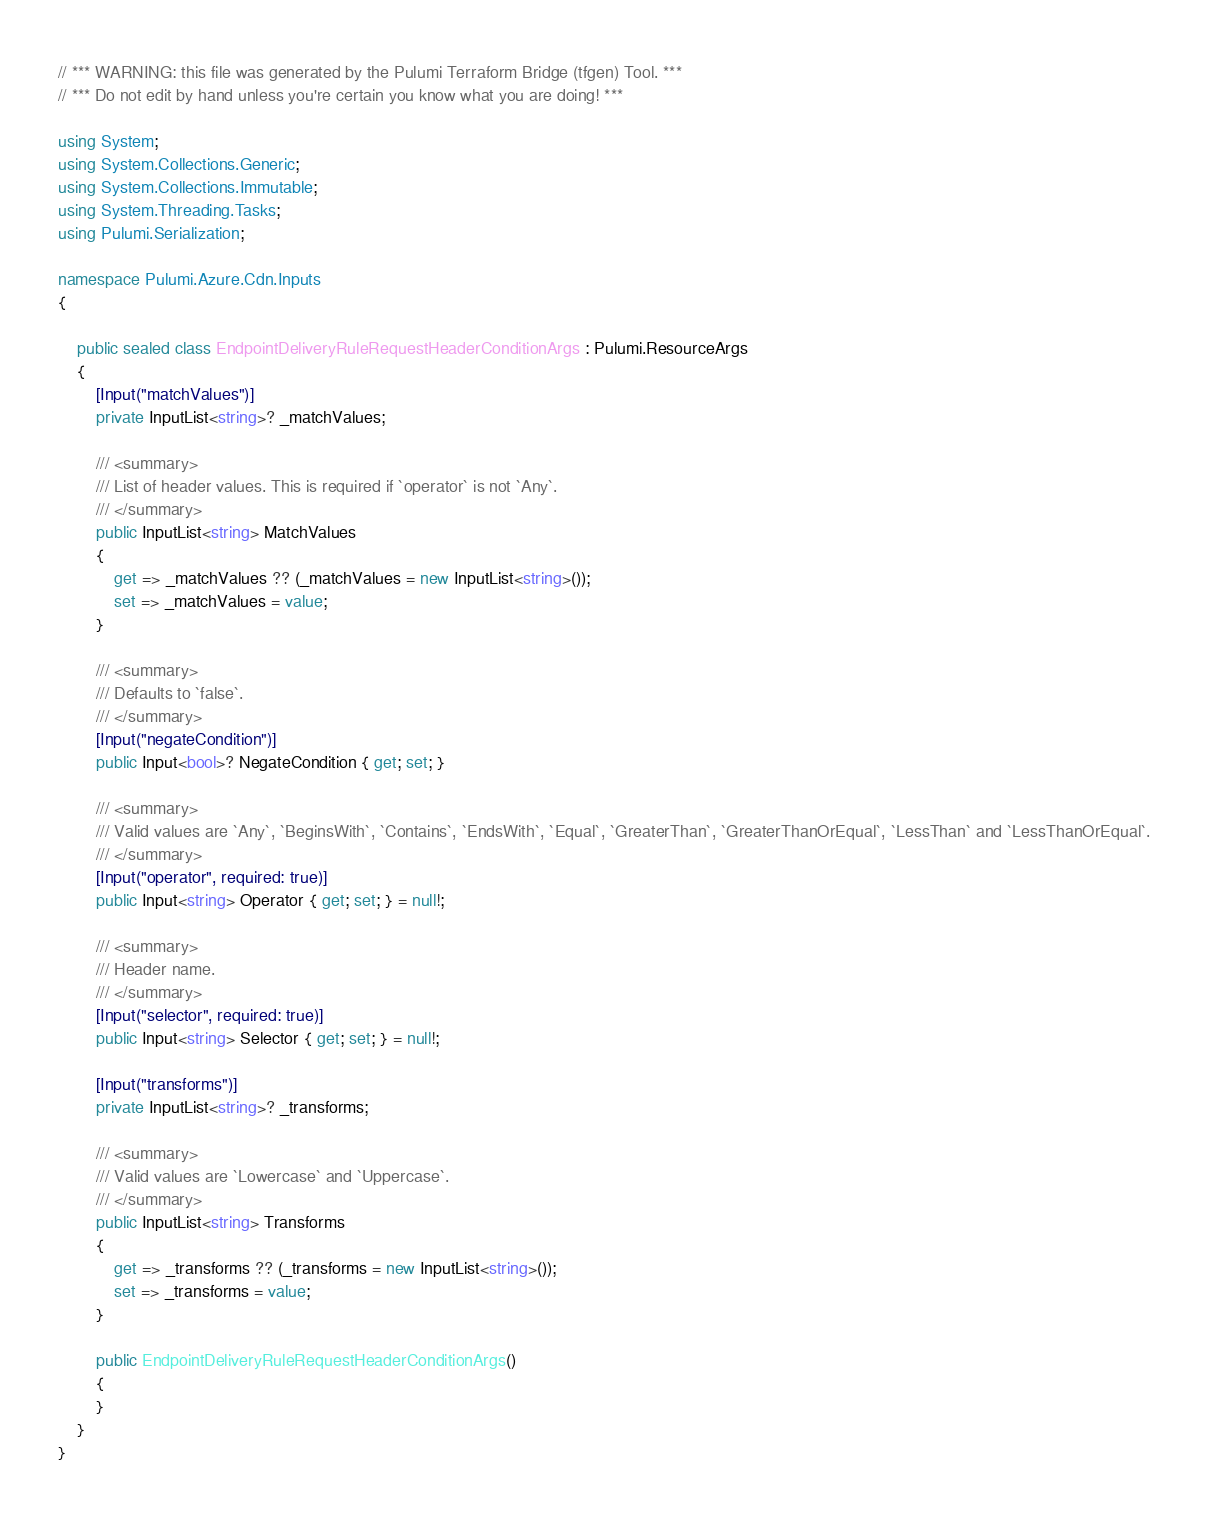Convert code to text. <code><loc_0><loc_0><loc_500><loc_500><_C#_>// *** WARNING: this file was generated by the Pulumi Terraform Bridge (tfgen) Tool. ***
// *** Do not edit by hand unless you're certain you know what you are doing! ***

using System;
using System.Collections.Generic;
using System.Collections.Immutable;
using System.Threading.Tasks;
using Pulumi.Serialization;

namespace Pulumi.Azure.Cdn.Inputs
{

    public sealed class EndpointDeliveryRuleRequestHeaderConditionArgs : Pulumi.ResourceArgs
    {
        [Input("matchValues")]
        private InputList<string>? _matchValues;

        /// <summary>
        /// List of header values. This is required if `operator` is not `Any`.
        /// </summary>
        public InputList<string> MatchValues
        {
            get => _matchValues ?? (_matchValues = new InputList<string>());
            set => _matchValues = value;
        }

        /// <summary>
        /// Defaults to `false`.
        /// </summary>
        [Input("negateCondition")]
        public Input<bool>? NegateCondition { get; set; }

        /// <summary>
        /// Valid values are `Any`, `BeginsWith`, `Contains`, `EndsWith`, `Equal`, `GreaterThan`, `GreaterThanOrEqual`, `LessThan` and `LessThanOrEqual`.
        /// </summary>
        [Input("operator", required: true)]
        public Input<string> Operator { get; set; } = null!;

        /// <summary>
        /// Header name.
        /// </summary>
        [Input("selector", required: true)]
        public Input<string> Selector { get; set; } = null!;

        [Input("transforms")]
        private InputList<string>? _transforms;

        /// <summary>
        /// Valid values are `Lowercase` and `Uppercase`.
        /// </summary>
        public InputList<string> Transforms
        {
            get => _transforms ?? (_transforms = new InputList<string>());
            set => _transforms = value;
        }

        public EndpointDeliveryRuleRequestHeaderConditionArgs()
        {
        }
    }
}
</code> 